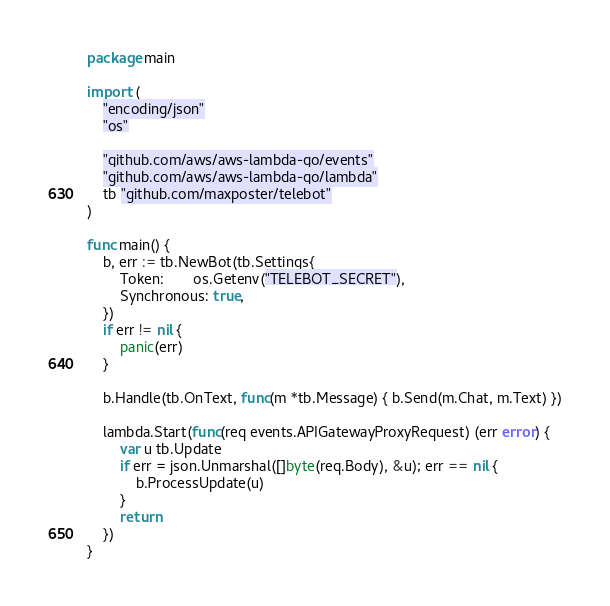Convert code to text. <code><loc_0><loc_0><loc_500><loc_500><_Go_>package main

import (
	"encoding/json"
	"os"

	"github.com/aws/aws-lambda-go/events"
	"github.com/aws/aws-lambda-go/lambda"
	tb "github.com/maxposter/telebot"
)

func main() {
	b, err := tb.NewBot(tb.Settings{
		Token:       os.Getenv("TELEBOT_SECRET"),
		Synchronous: true,
	})
	if err != nil {
		panic(err)
	}

	b.Handle(tb.OnText, func(m *tb.Message) { b.Send(m.Chat, m.Text) })

	lambda.Start(func(req events.APIGatewayProxyRequest) (err error) {
		var u tb.Update
		if err = json.Unmarshal([]byte(req.Body), &u); err == nil {
			b.ProcessUpdate(u)
		}
		return
	})
}
</code> 